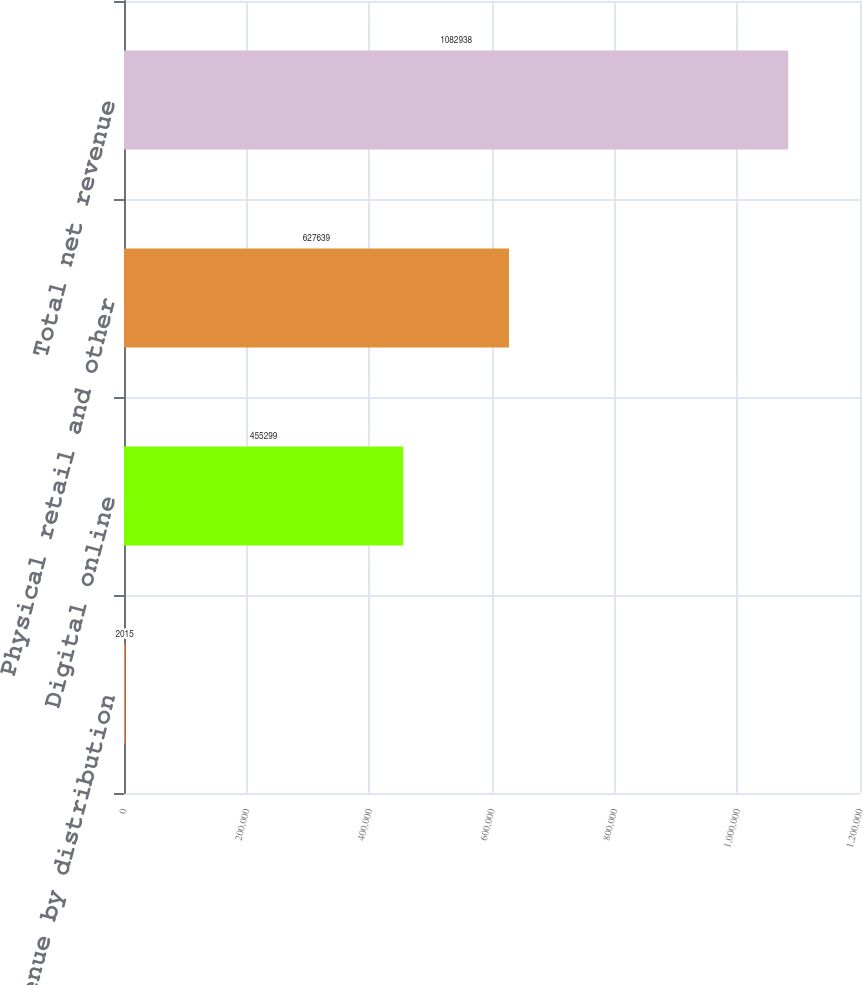Convert chart. <chart><loc_0><loc_0><loc_500><loc_500><bar_chart><fcel>Net revenue by distribution<fcel>Digital online<fcel>Physical retail and other<fcel>Total net revenue<nl><fcel>2015<fcel>455299<fcel>627639<fcel>1.08294e+06<nl></chart> 